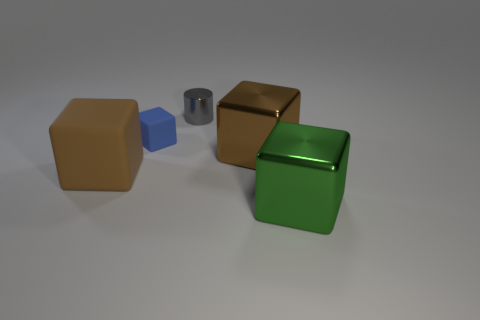What number of small blocks have the same material as the gray object?
Make the answer very short. 0. How many large brown cubes are on the right side of the big brown thing that is on the left side of the tiny gray shiny object?
Provide a succinct answer. 1. There is a large shiny block left of the big green block; is its color the same as the large block to the right of the big brown metal cube?
Keep it short and to the point. No. The metal object that is both left of the green block and in front of the tiny shiny cylinder has what shape?
Make the answer very short. Cube. Are there any other large things of the same shape as the gray metallic object?
Provide a succinct answer. No. There is a object that is the same size as the blue cube; what shape is it?
Your answer should be compact. Cylinder. What material is the large green thing?
Ensure brevity in your answer.  Metal. There is a shiny thing that is to the right of the brown block that is behind the matte block on the left side of the blue block; how big is it?
Provide a short and direct response. Large. There is a cube that is the same color as the big rubber thing; what is its material?
Your answer should be compact. Metal. How many metallic objects are yellow spheres or green cubes?
Provide a short and direct response. 1. 